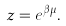Convert formula to latex. <formula><loc_0><loc_0><loc_500><loc_500>z = e ^ { \beta \mu } .</formula> 